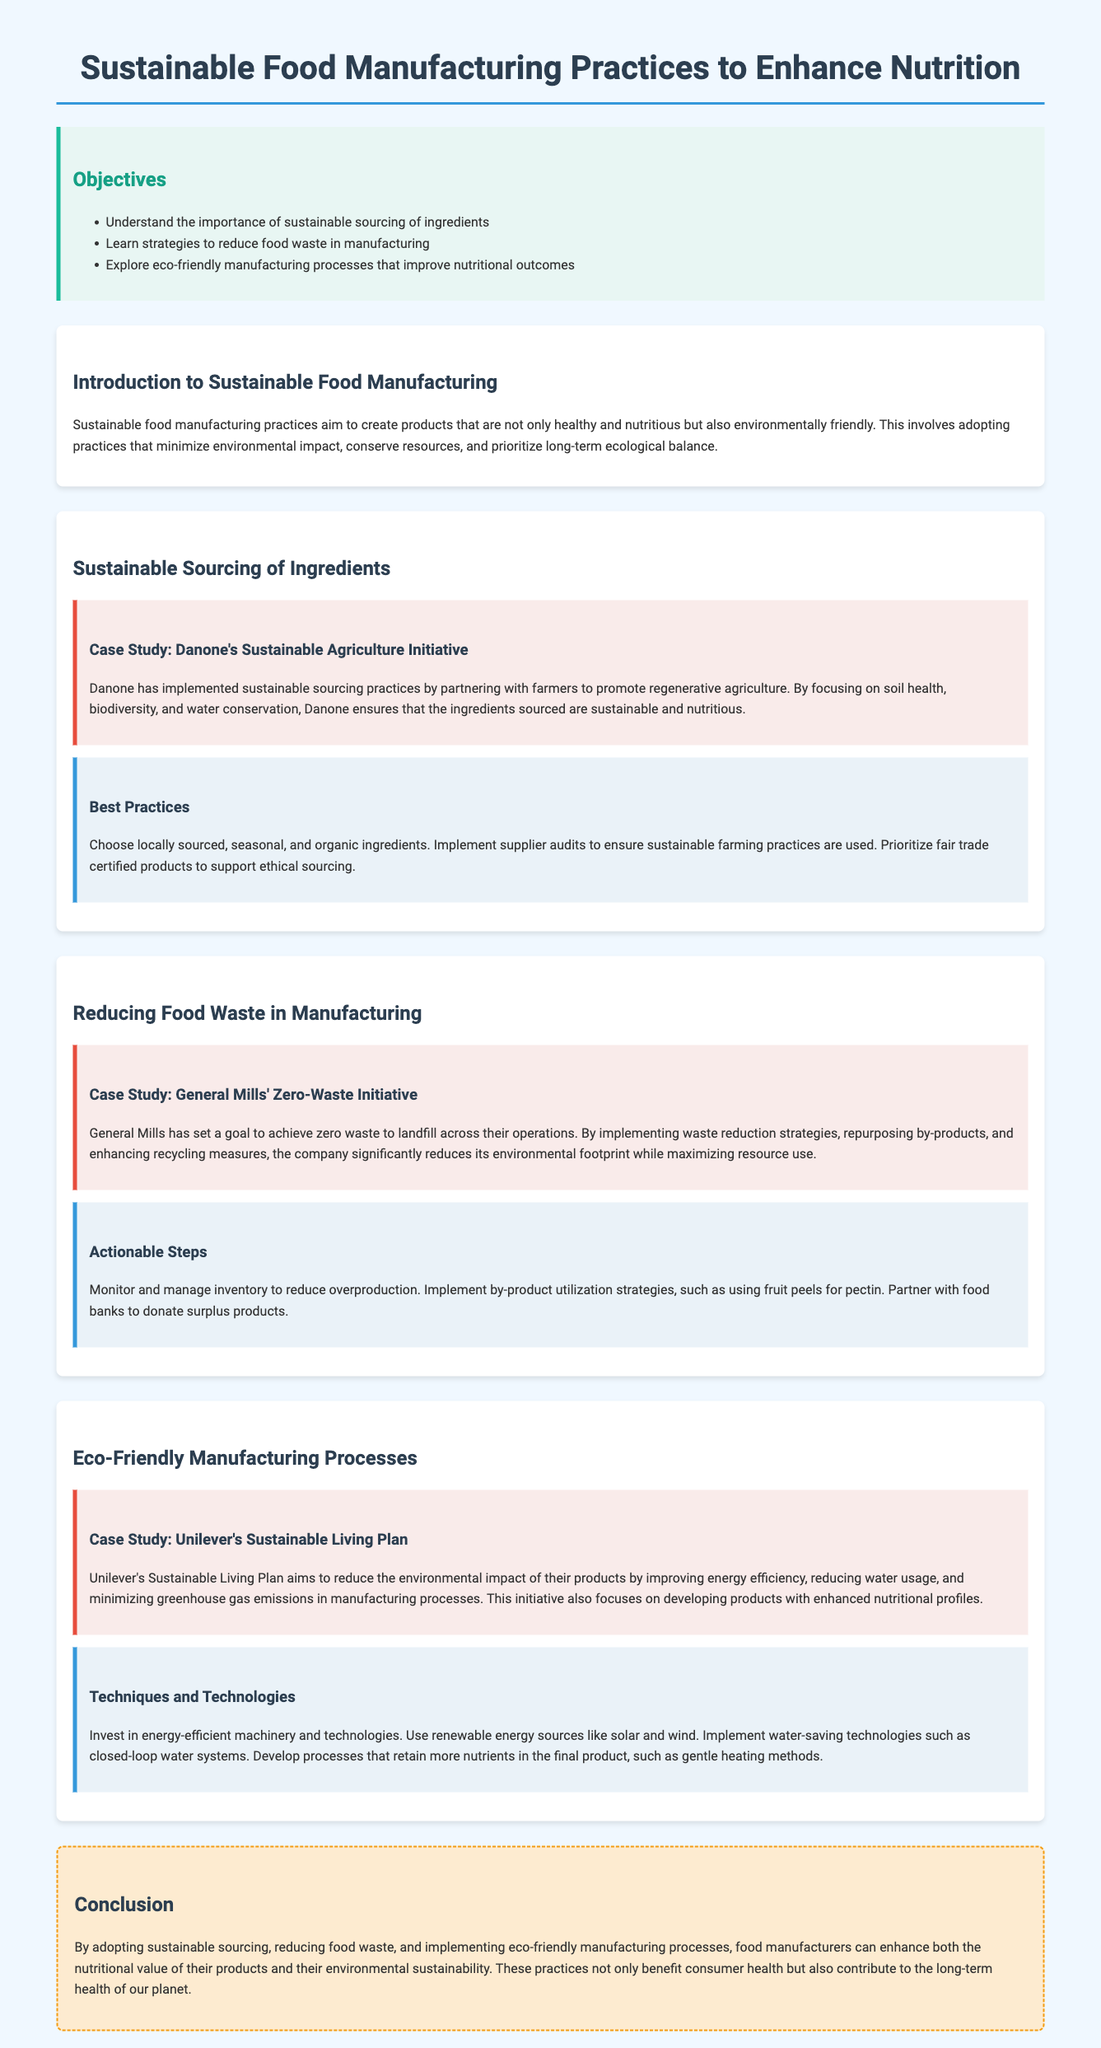What are the objectives of the lesson? The objectives of the lesson are listed in the document and include understanding sustainable sourcing, reducing food waste, and exploring eco-friendly processes.
Answer: Sustainable sourcing, reducing food waste, eco-friendly processes Who is mentioned in the case study for sustainable sourcing? The case study highlighted in the section on sustainable sourcing discusses Danone's practices related to sourcing ingredients.
Answer: Danone What is the goal of General Mills as mentioned in the document? The document states that General Mills has set a goal to achieve zero waste to landfill across their operations.
Answer: Zero waste What recycling strategy is noted in General Mills' case study? The case study discusses the implementation of waste reduction strategies and repurposing by-products at General Mills.
Answer: Repurposing by-products What does Unilever focus on in its Sustainable Living Plan? Unilever’s strategy is aimed at reducing environmental impact and improving nutritional profiles in their products, as stated in the case study.
Answer: Nutritional profiles Which techniques are suggested for eco-friendly manufacturing processes? The document mentions investing in energy-efficient machinery among the techniques for eco-friendly manufacturing processes.
Answer: Energy-efficient machinery What is the desired outcome of implementing sustainable practices in food manufacturing? The conclusion emphasizes enhancing nutritional value and environmental sustainability as the desired outcomes of sustainable practices.
Answer: Nutritional value and environmental sustainability List a best practice for sustainable sourcing of ingredients. The document suggests choosing locally sourced, seasonal, and organic ingredients as a best practice for sustainable sourcing.
Answer: Locally sourced, seasonal, and organic ingredients 